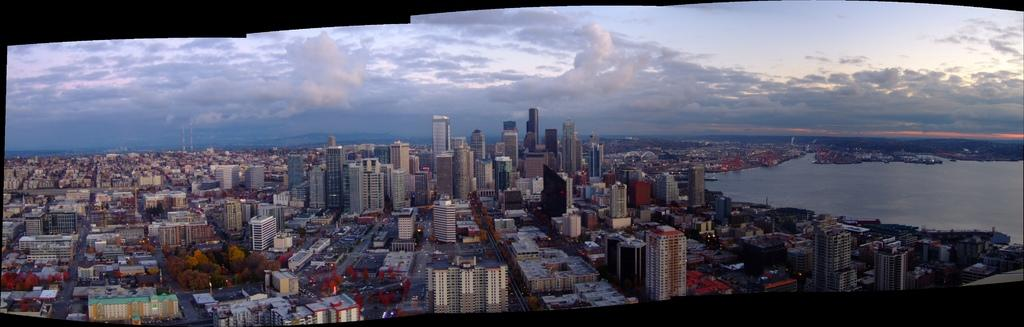What types of structures are present in the image? There are buildings and houses in the image. What else can be seen in the image besides structures? There are trees, roads, and water visible in the image. What is the condition of the sky in the image? The sky is cloudy at the top of the image. What shape is the caption in the image? There is no caption present in the image, so it cannot have a shape. What type of competition is taking place in the image? There is no competition depicted in the image. 